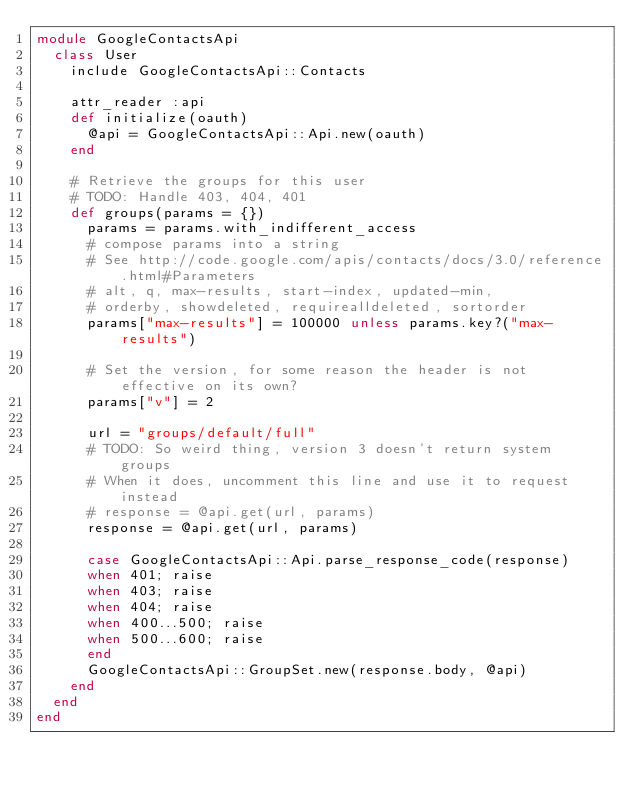Convert code to text. <code><loc_0><loc_0><loc_500><loc_500><_Ruby_>module GoogleContactsApi
  class User
    include GoogleContactsApi::Contacts
    
    attr_reader :api
    def initialize(oauth)
      @api = GoogleContactsApi::Api.new(oauth)
    end

    # Retrieve the groups for this user
    # TODO: Handle 403, 404, 401
    def groups(params = {})
      params = params.with_indifferent_access
      # compose params into a string
      # See http://code.google.com/apis/contacts/docs/3.0/reference.html#Parameters
      # alt, q, max-results, start-index, updated-min,
      # orderby, showdeleted, requirealldeleted, sortorder
      params["max-results"] = 100000 unless params.key?("max-results")

      # Set the version, for some reason the header is not effective on its own?
      params["v"] = 2

      url = "groups/default/full"
      # TODO: So weird thing, version 3 doesn't return system groups
      # When it does, uncomment this line and use it to request instead
      # response = @api.get(url, params)
      response = @api.get(url, params)

      case GoogleContactsApi::Api.parse_response_code(response)
      when 401; raise
      when 403; raise
      when 404; raise
      when 400...500; raise
      when 500...600; raise
      end
      GoogleContactsApi::GroupSet.new(response.body, @api)
    end
  end
end</code> 